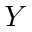<formula> <loc_0><loc_0><loc_500><loc_500>Y</formula> 